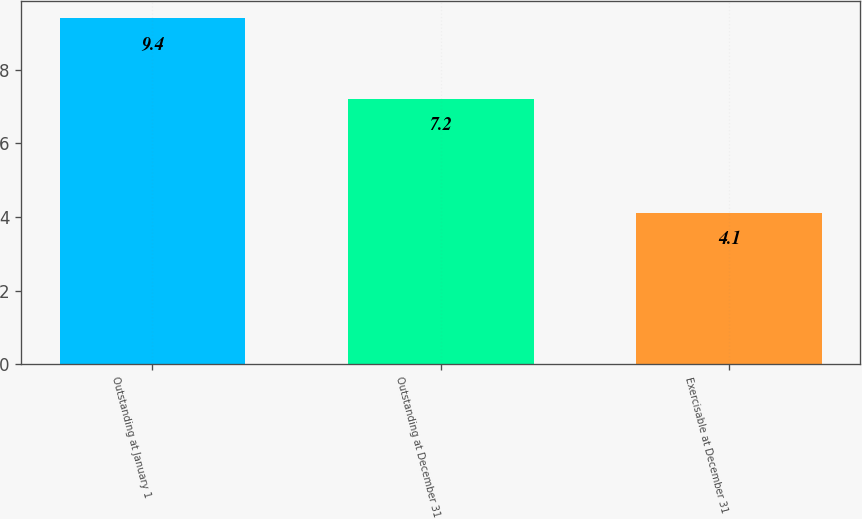Convert chart to OTSL. <chart><loc_0><loc_0><loc_500><loc_500><bar_chart><fcel>Outstanding at January 1<fcel>Outstanding at December 31<fcel>Exercisable at December 31<nl><fcel>9.4<fcel>7.2<fcel>4.1<nl></chart> 